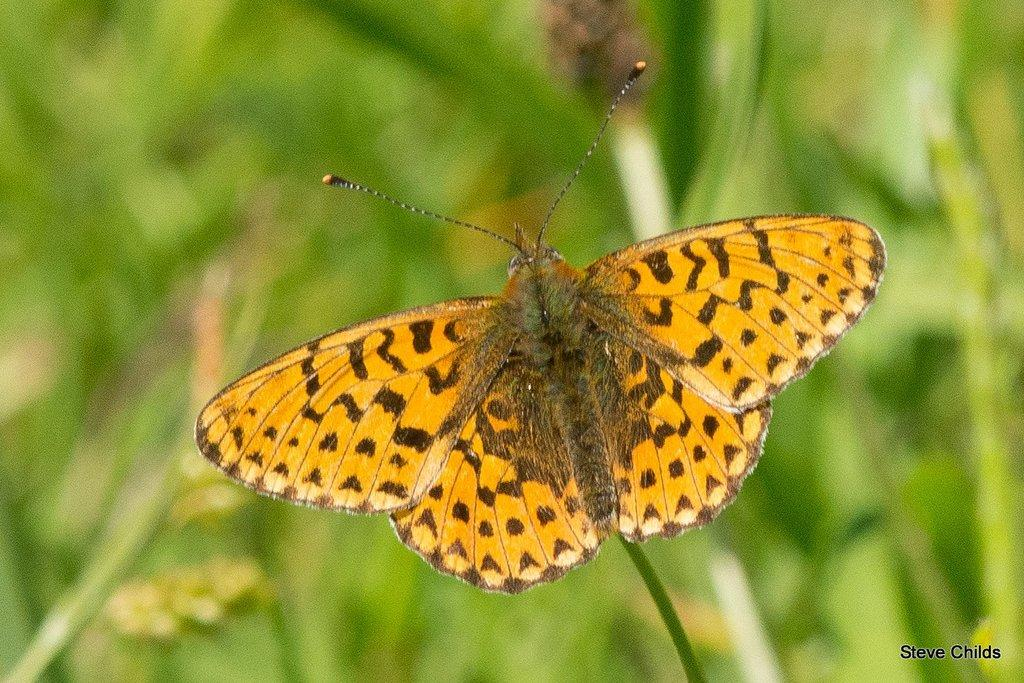What is the main subject of the image? There is a picture of a butterfly in the image. Where is the butterfly located in the image? The butterfly is in the middle of the image. Is there any text present in the image? Yes, there is text at the bottom right corner of the image. How many stamps are visible on the butterfly's wings in the image? There are no stamps visible on the butterfly's wings in the image. What type of line is drawn across the butterfly's body in the image? There is no line drawn across the butterfly's body in the image. 